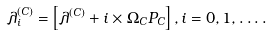<formula> <loc_0><loc_0><loc_500><loc_500>\lambda _ { i } ^ { ( C ) } = \left [ { \lambda ^ { ( C ) } + i \times \Omega _ { C } P _ { C } } \right ] , i = 0 , 1 , \dots .</formula> 